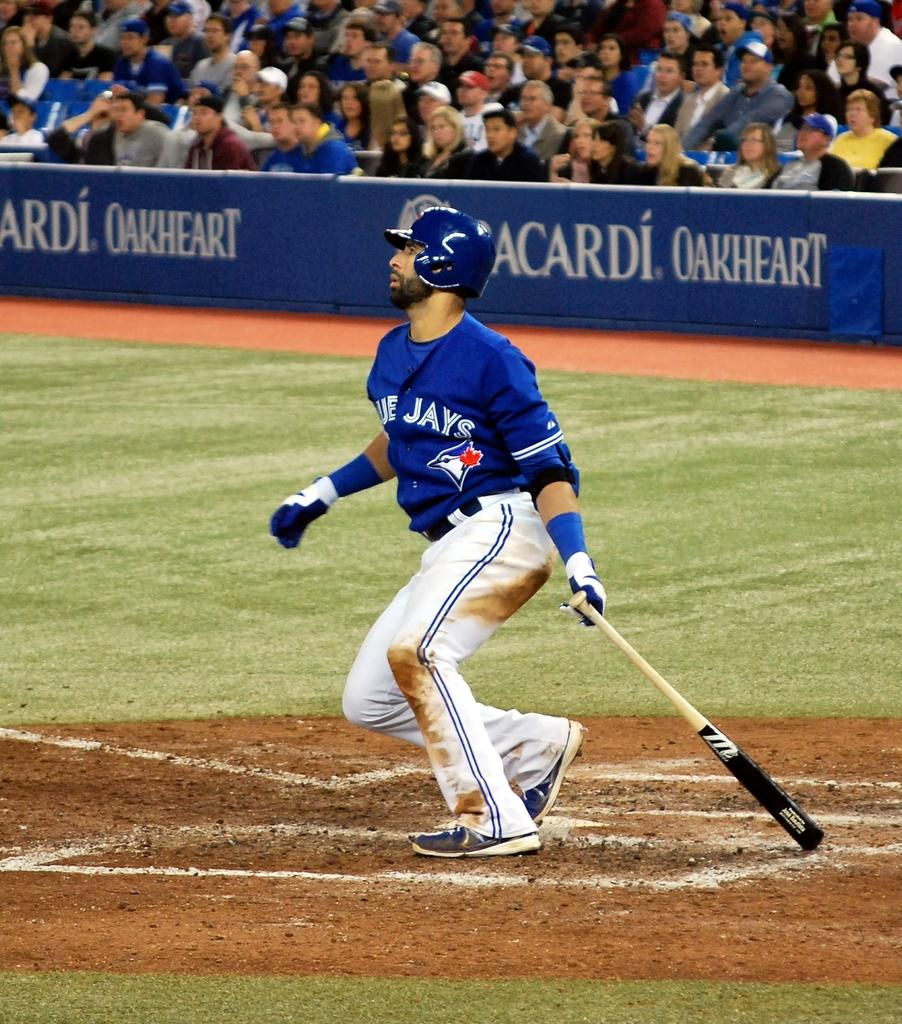What is the person in the image holding? The person in the image is holding a baseball bat. What else can be seen in the image besides the person with the baseball bat? There is a poster with text in the image. Where are the people in the image sitting? The audience is sitting behind the person and the poster. What type of crow can be seen perched on the edge of the baseball bat in the image? There is no crow present in the image, and the baseball bat is not depicted as having an edge for a crow to perch on. 